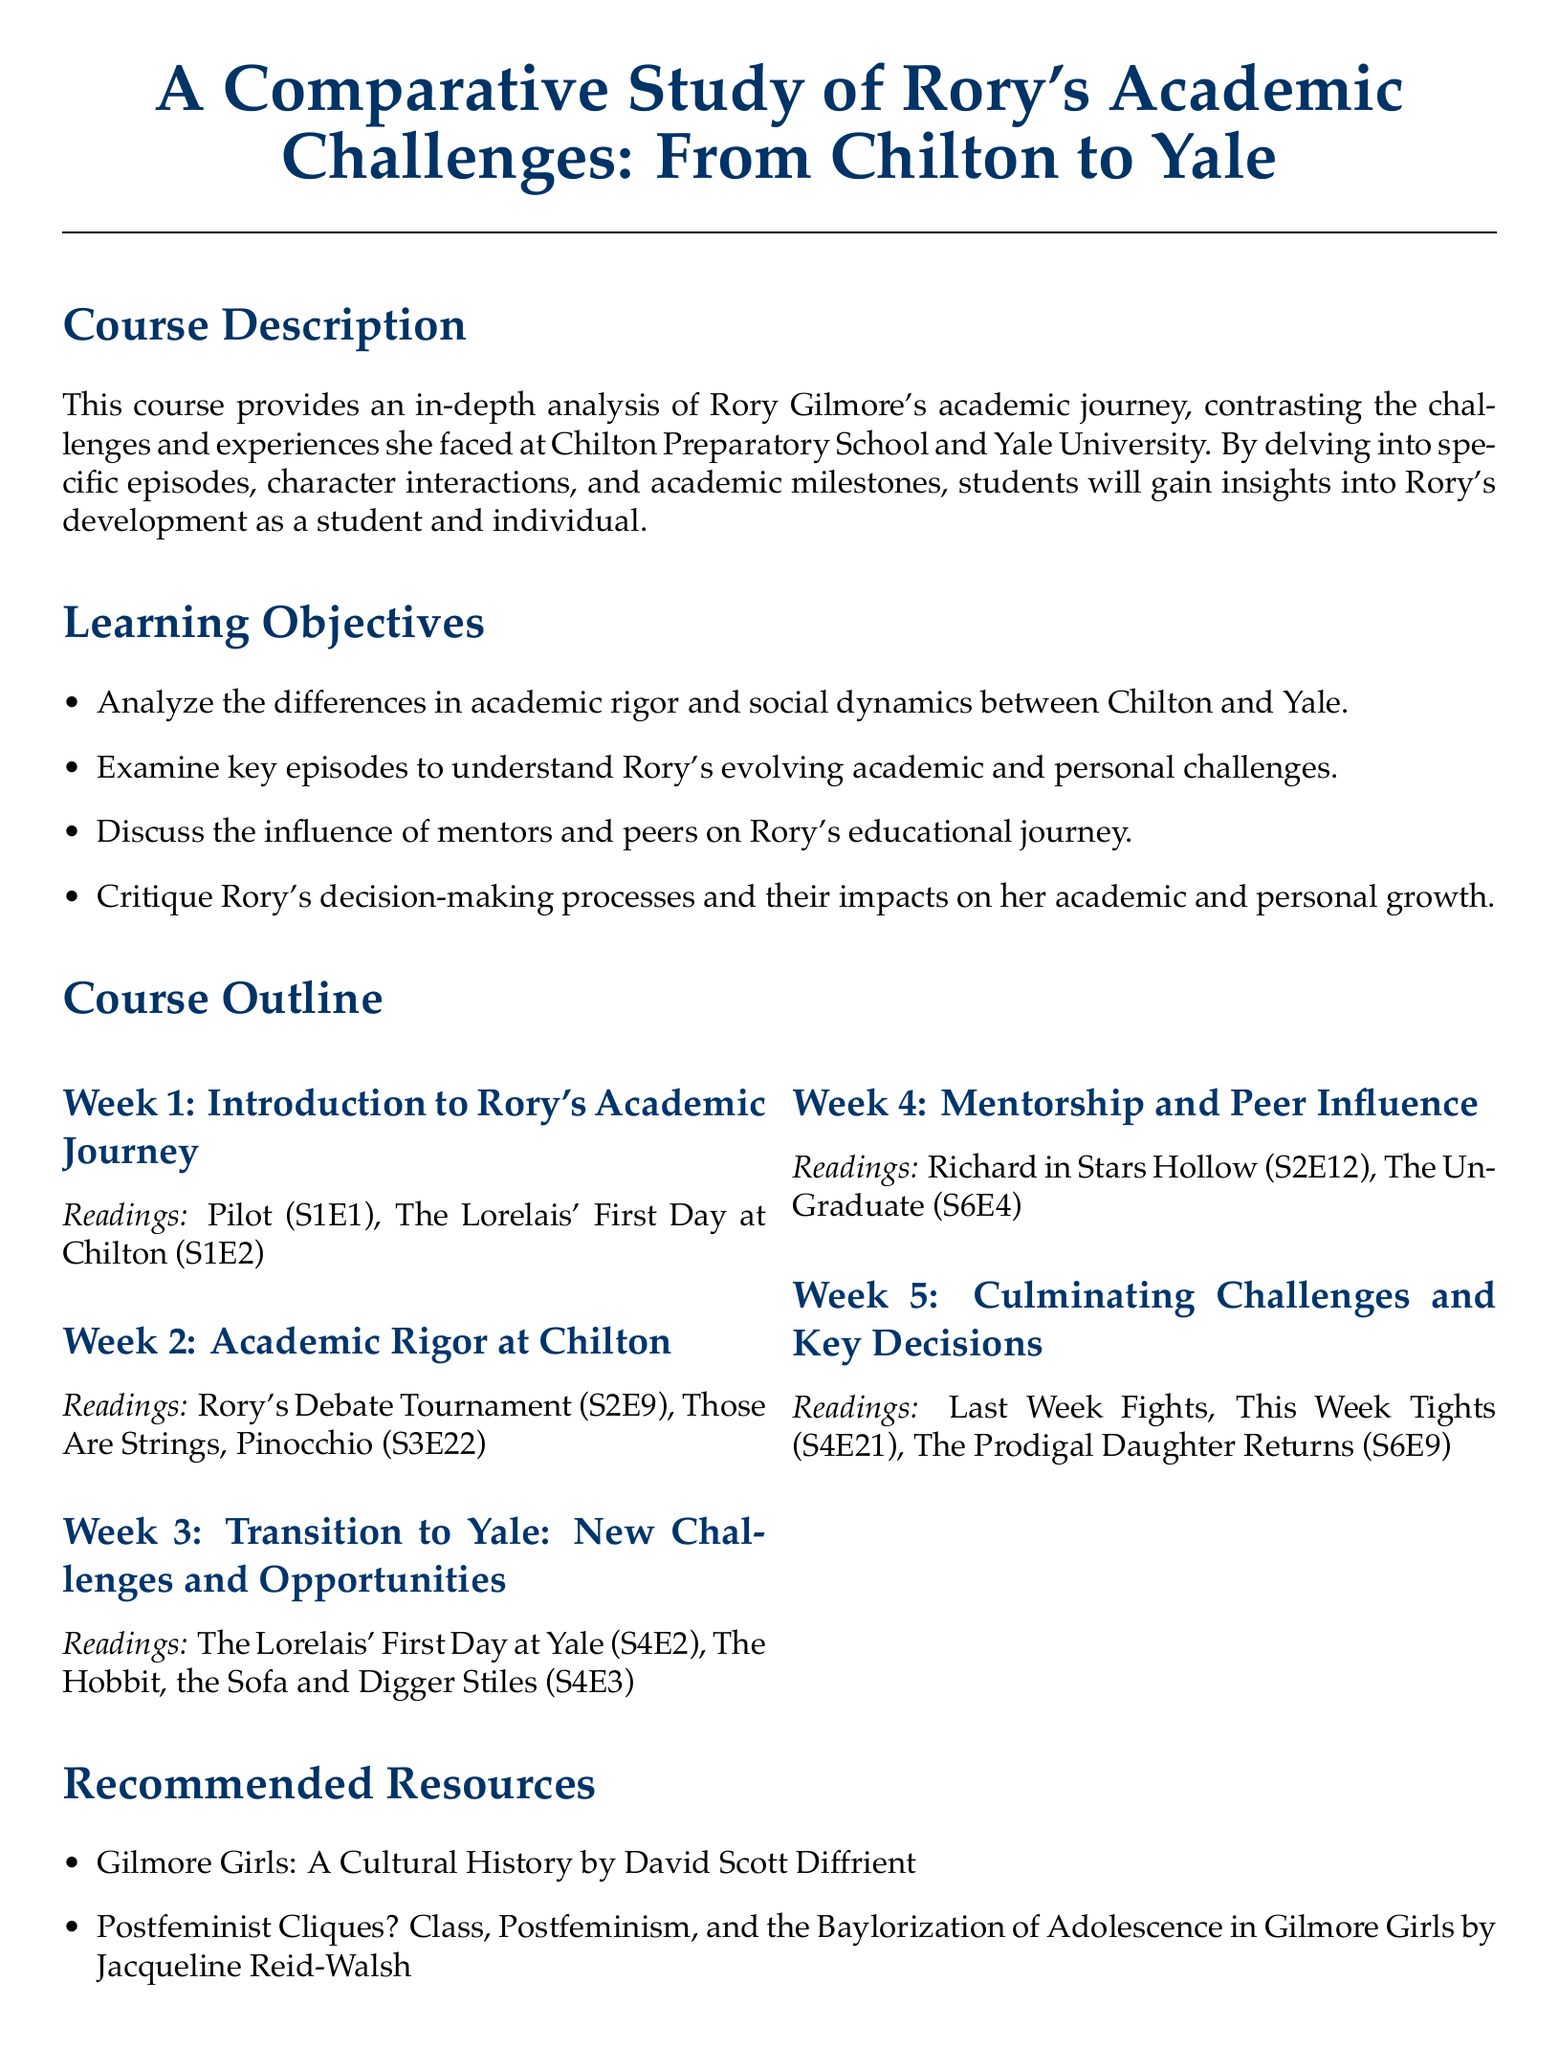What is the title of the course? The title of the course is provided at the beginning of the document and is "A Comparative Study of Rory's Academic Challenges: From Chilton to Yale."
Answer: A Comparative Study of Rory's Academic Challenges: From Chilton to Yale What is one of the learning objectives? The learning objectives are listed in a bullet point format, and one of them is to analyze the differences in academic rigor and social dynamics between Chilton and Yale.
Answer: Analyze the differences in academic rigor and social dynamics between Chilton and Yale How many weeks is the course outline divided into? The course outline is divided into five weeks as indicated by the sections.
Answer: 5 What episode is referenced in Week 3 readings? Week 3 includes readings from episodes which are "The Lorelais' First Day at Yale" and "The Hobbit, the Sofa and Digger Stiles."
Answer: The Lorelais' First Day at Yale What type of assessment method involves class discussions? The assessment methods include various forms of evaluation, and class discussions are part of the participation category.
Answer: Class discussions and participation Which resource focuses on postfeminism? The document lists a recommended resource titled "Postfeminist Cliques? Class, Postfeminism, and the Baylorization of Adolescence in Gilmore Girls."
Answer: Postfeminist Cliques? Class, Postfeminism, and the Baylorization of Adolescence in Gilmore Girls What is the color associated with Chilton in the syllabus? The syllabus uses specific colors to represent different sections, and Chilton is associated with the color specified as blue with RGB values of 0, 51, 102.
Answer: chiltonblue What is the total number of assessment methods listed? The document enumerates assessment methods, and there are four assessment methods mentioned in total.
Answer: 4 